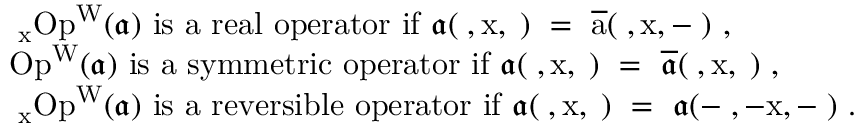<formula> <loc_0><loc_0><loc_500><loc_500>\begin{array} { r l } & { \partial _ { x } O p ^ { W } ( \mathfrak { a } ) i s a r e a l o p e r a t o r i f \mathfrak { a } ( \varphi , x , \xi ) = \overline { a } ( \varphi , x , - \xi ) , } \\ & { O p ^ { W } ( \mathfrak { a } ) i s a s y m m e t r i c o p e r a t o r i f \mathfrak { a } ( \varphi , x , \xi ) = \overline { { \mathfrak { a } } } ( \varphi , x , \xi ) , } \\ & { \partial _ { x } O p ^ { W } ( \mathfrak { a } ) i s a r e v e r s i b l e o p e r a t o r i f \mathfrak { a } ( \varphi , x , \xi ) = \mathfrak { a } ( - \varphi , - x , - \xi ) . } \end{array}</formula> 